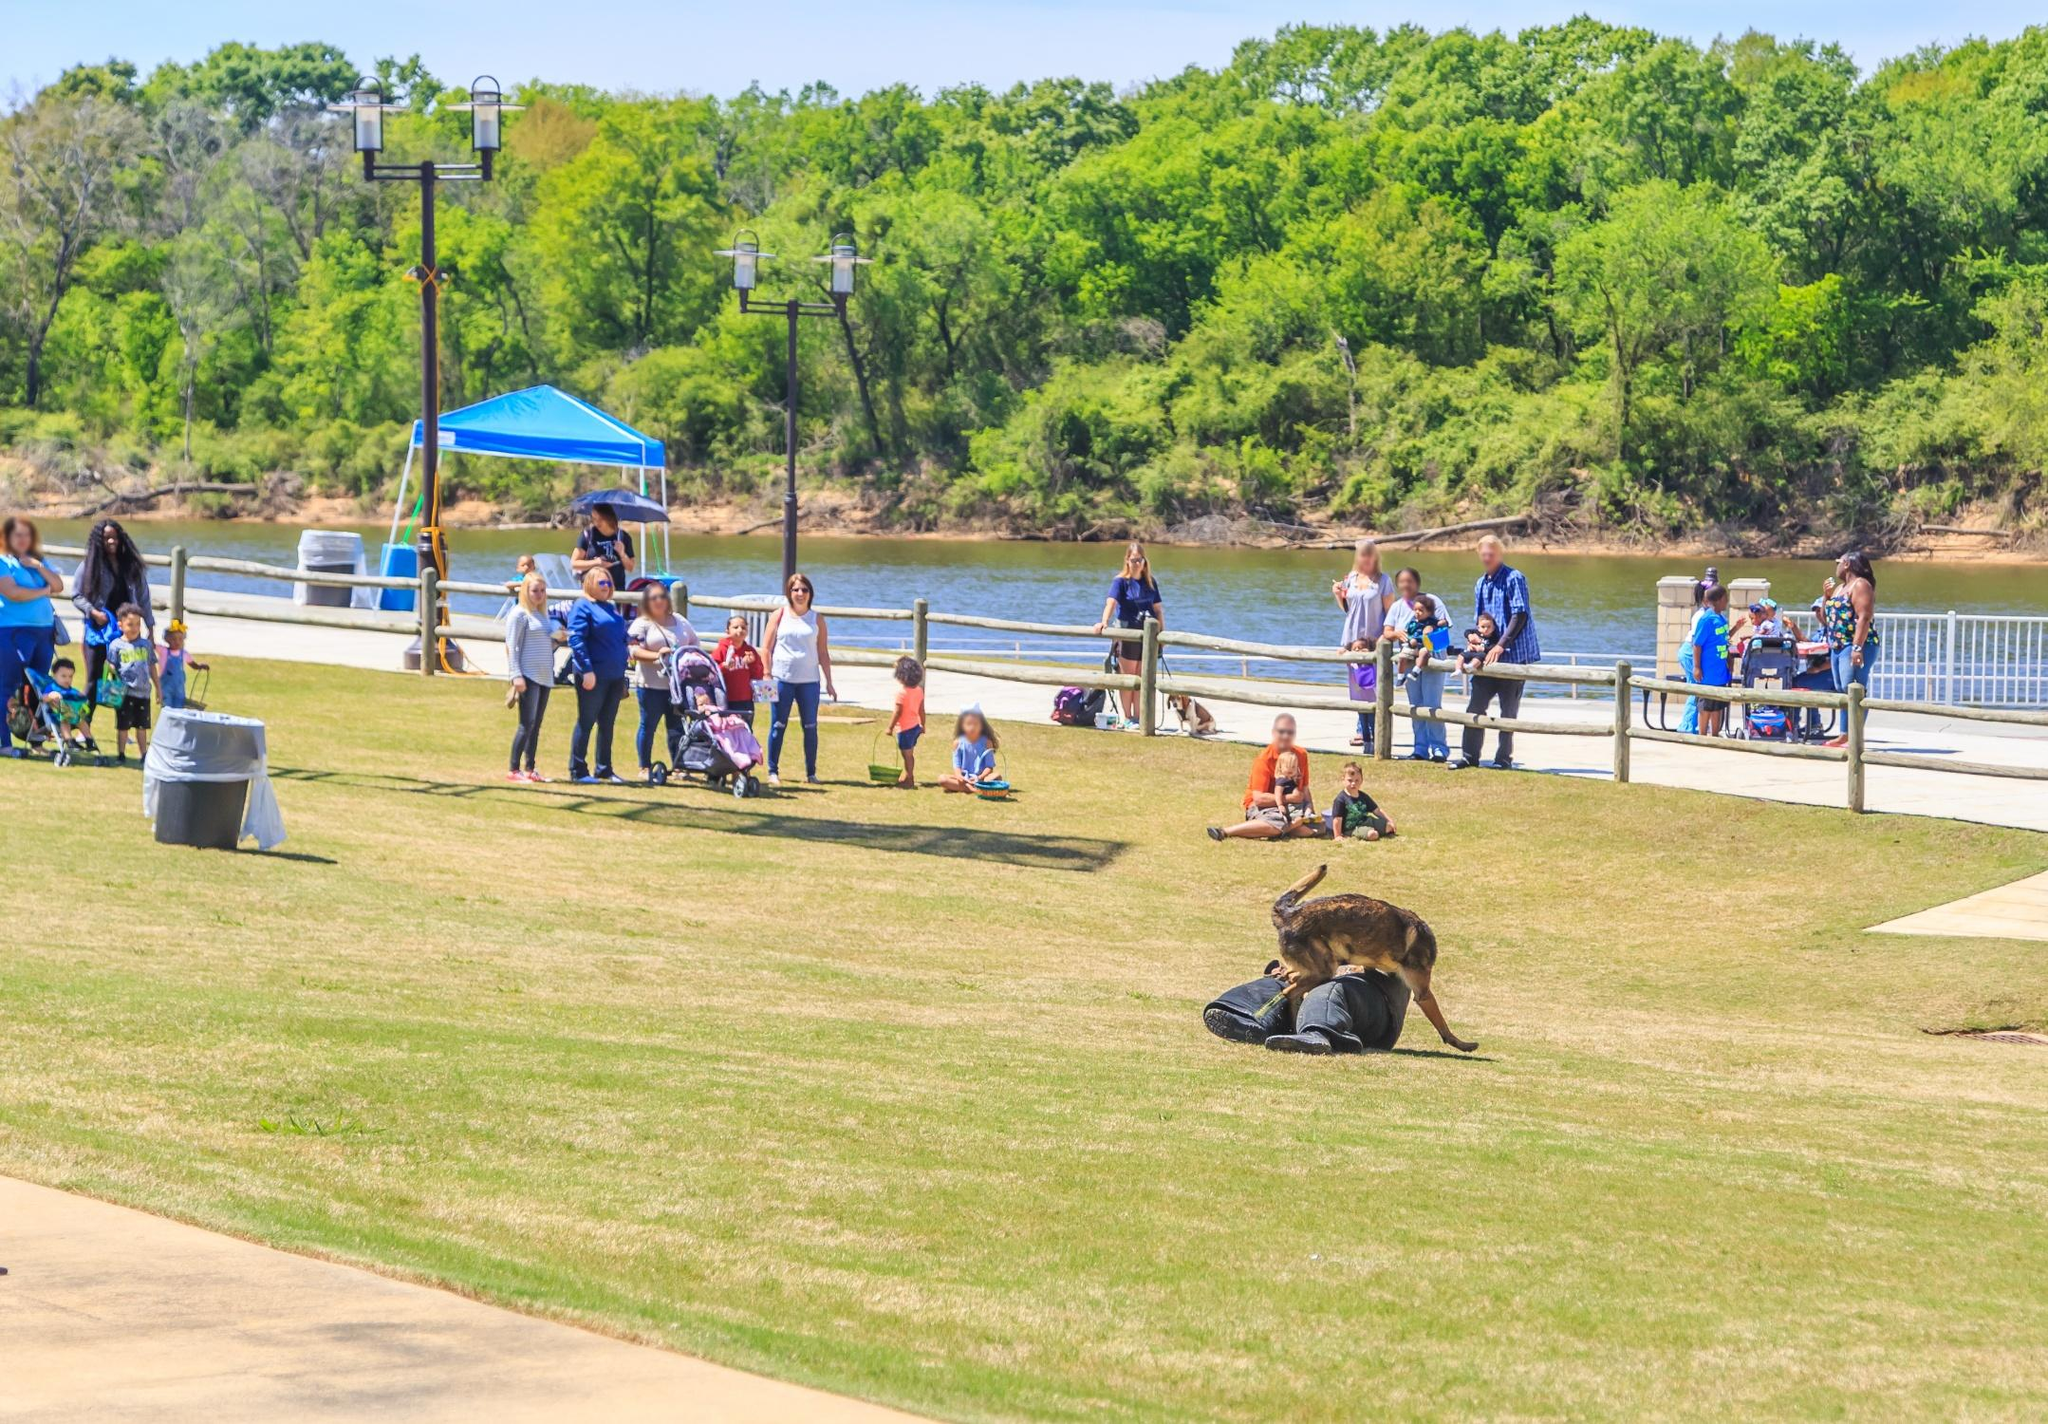Analyze the image in a comprehensive and detailed manner. This is a high-angle view capturing a vibrant scene in a park adjacent to a serene river. The park is bustling with numerous visitors who are enjoying their day out in nature. A meandering walkway along the riverfront invites leisurely strolls. In the foreground, there is a dog curiously inspecting a backpack, likely belonging to one of the park visitors. Additionally, a blue canopy is set up, offering a shaded rest area. The natural beauty of the river is accentuated by the lush greenery of the surrounding trees. The overall ambiance is one of relaxation and enjoyment, as people of various ages engage in outdoor activities. 